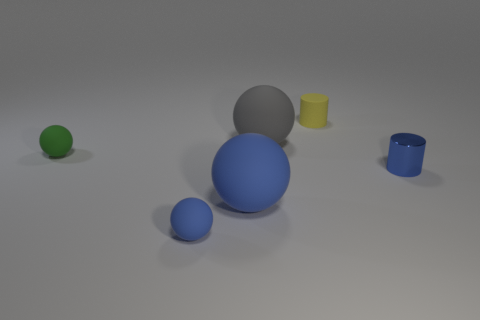Add 3 tiny yellow rubber spheres. How many objects exist? 9 Subtract all yellow cylinders. How many cylinders are left? 1 Subtract all balls. How many objects are left? 2 Subtract 2 balls. How many balls are left? 2 Subtract all green cylinders. How many purple balls are left? 0 Subtract all tiny yellow matte things. Subtract all large blue rubber balls. How many objects are left? 4 Add 5 tiny green matte things. How many tiny green matte things are left? 6 Add 4 brown things. How many brown things exist? 4 Subtract 0 purple blocks. How many objects are left? 6 Subtract all cyan cylinders. Subtract all yellow blocks. How many cylinders are left? 2 